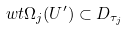<formula> <loc_0><loc_0><loc_500><loc_500>\ w t \Omega _ { j } ( U ^ { \prime } ) \subset D _ { \tau _ { j } }</formula> 